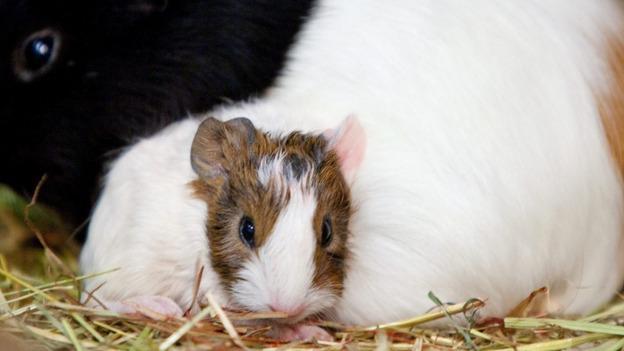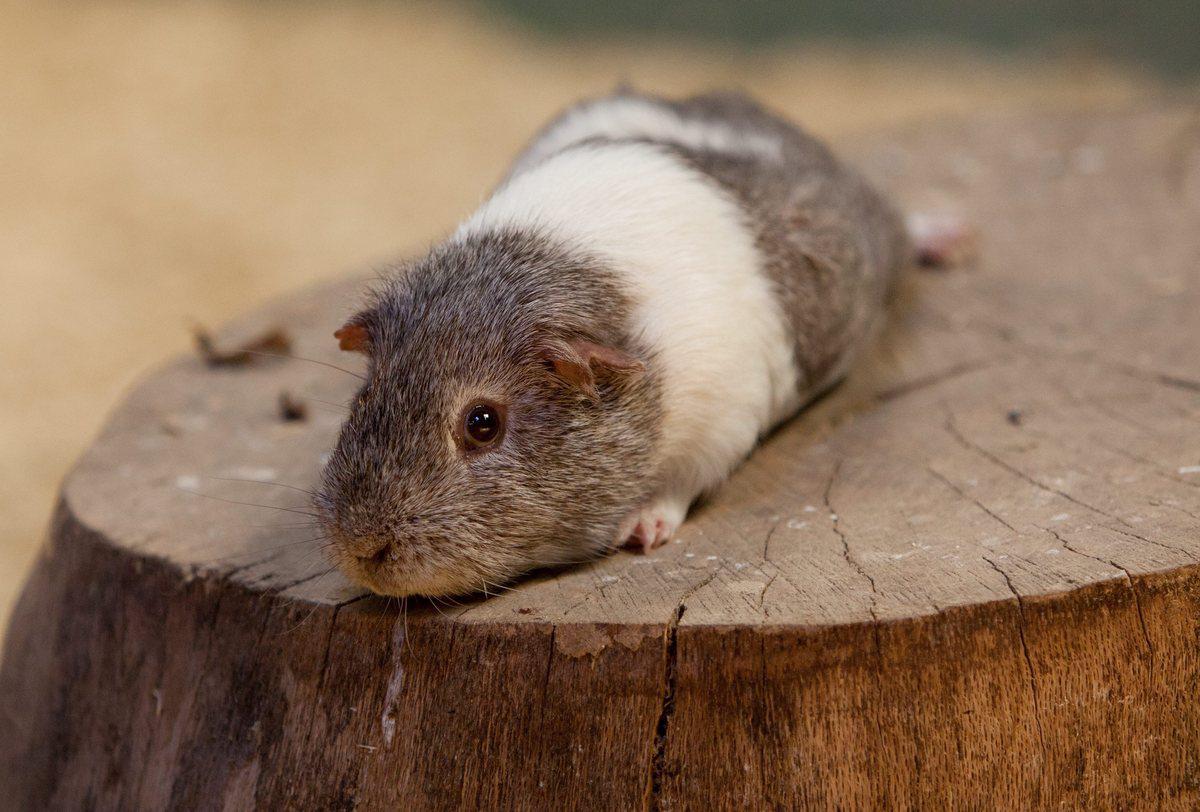The first image is the image on the left, the second image is the image on the right. Given the left and right images, does the statement "All of the four hamsters have different color patterns and none of them are eating." hold true? Answer yes or no. No. The first image is the image on the left, the second image is the image on the right. Assess this claim about the two images: "There are three guinea pigs huddled up closely together in one picture of both pairs.". Correct or not? Answer yes or no. No. 